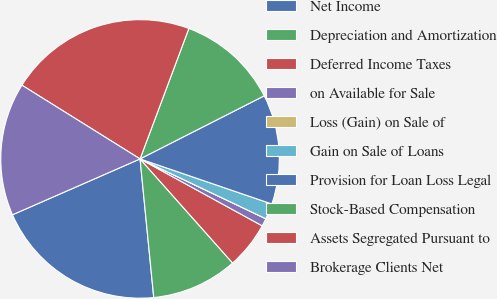Convert chart. <chart><loc_0><loc_0><loc_500><loc_500><pie_chart><fcel>Net Income<fcel>Depreciation and Amortization<fcel>Deferred Income Taxes<fcel>on Available for Sale<fcel>Loss (Gain) on Sale of<fcel>Gain on Sale of Loans<fcel>Provision for Loan Loss Legal<fcel>Stock-Based Compensation<fcel>Assets Segregated Pursuant to<fcel>Brokerage Clients Net<nl><fcel>20.0%<fcel>10.0%<fcel>5.46%<fcel>0.91%<fcel>0.0%<fcel>1.82%<fcel>12.73%<fcel>11.82%<fcel>21.82%<fcel>15.45%<nl></chart> 